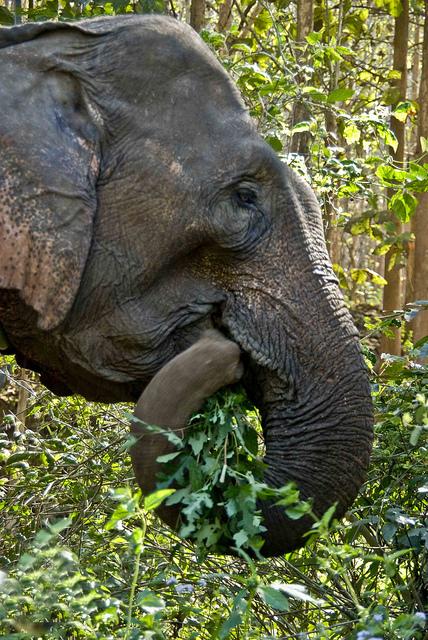Is the elephant happy?
Write a very short answer. Yes. Does this elephant have tusks?
Concise answer only. No. What is the elephant doing?
Be succinct. Eating. 